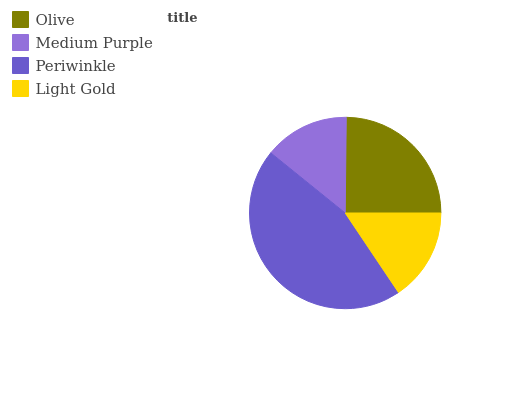Is Medium Purple the minimum?
Answer yes or no. Yes. Is Periwinkle the maximum?
Answer yes or no. Yes. Is Periwinkle the minimum?
Answer yes or no. No. Is Medium Purple the maximum?
Answer yes or no. No. Is Periwinkle greater than Medium Purple?
Answer yes or no. Yes. Is Medium Purple less than Periwinkle?
Answer yes or no. Yes. Is Medium Purple greater than Periwinkle?
Answer yes or no. No. Is Periwinkle less than Medium Purple?
Answer yes or no. No. Is Olive the high median?
Answer yes or no. Yes. Is Light Gold the low median?
Answer yes or no. Yes. Is Medium Purple the high median?
Answer yes or no. No. Is Olive the low median?
Answer yes or no. No. 